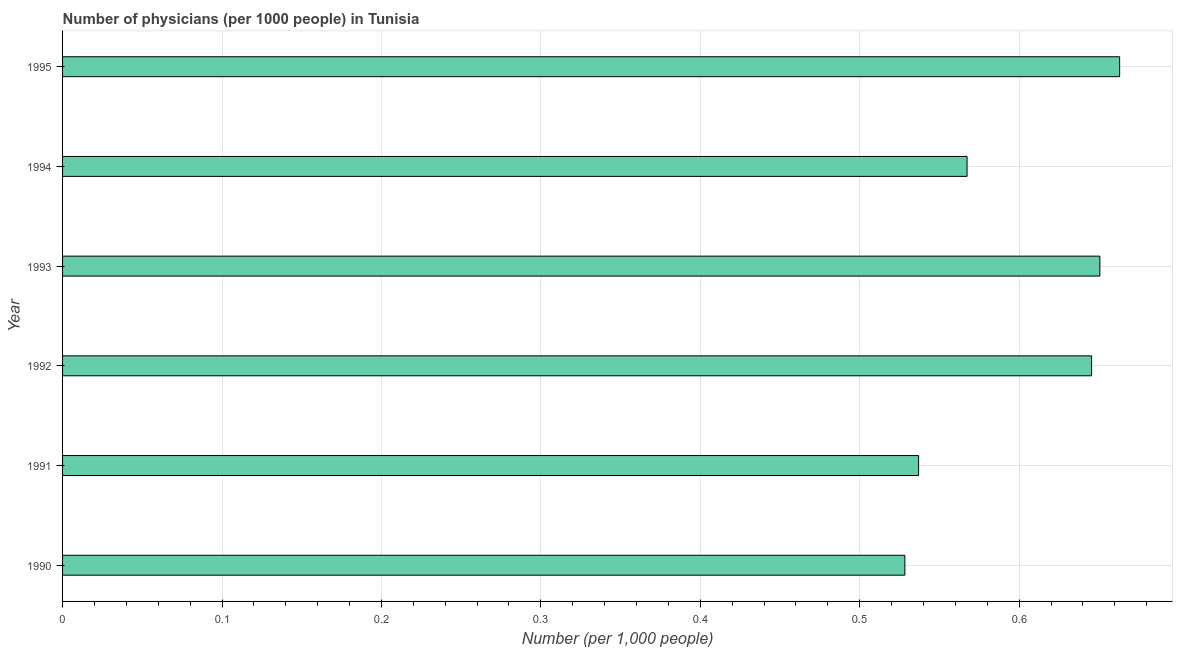Does the graph contain grids?
Offer a terse response. Yes. What is the title of the graph?
Offer a very short reply. Number of physicians (per 1000 people) in Tunisia. What is the label or title of the X-axis?
Give a very brief answer. Number (per 1,0 people). What is the label or title of the Y-axis?
Offer a terse response. Year. What is the number of physicians in 1991?
Your response must be concise. 0.54. Across all years, what is the maximum number of physicians?
Provide a succinct answer. 0.66. Across all years, what is the minimum number of physicians?
Provide a short and direct response. 0.53. In which year was the number of physicians minimum?
Your answer should be compact. 1990. What is the sum of the number of physicians?
Your response must be concise. 3.59. What is the difference between the number of physicians in 1991 and 1994?
Provide a short and direct response. -0.03. What is the average number of physicians per year?
Make the answer very short. 0.6. What is the median number of physicians?
Provide a short and direct response. 0.61. What is the ratio of the number of physicians in 1991 to that in 1994?
Offer a terse response. 0.95. Is the number of physicians in 1993 less than that in 1994?
Your answer should be very brief. No. Is the difference between the number of physicians in 1990 and 1991 greater than the difference between any two years?
Your answer should be very brief. No. What is the difference between the highest and the second highest number of physicians?
Your answer should be compact. 0.01. Is the sum of the number of physicians in 1992 and 1995 greater than the maximum number of physicians across all years?
Provide a short and direct response. Yes. What is the difference between the highest and the lowest number of physicians?
Keep it short and to the point. 0.13. How many bars are there?
Keep it short and to the point. 6. What is the Number (per 1,000 people) of 1990?
Give a very brief answer. 0.53. What is the Number (per 1,000 people) of 1991?
Your answer should be compact. 0.54. What is the Number (per 1,000 people) in 1992?
Offer a very short reply. 0.65. What is the Number (per 1,000 people) of 1993?
Your answer should be compact. 0.65. What is the Number (per 1,000 people) in 1994?
Ensure brevity in your answer.  0.57. What is the Number (per 1,000 people) of 1995?
Offer a terse response. 0.66. What is the difference between the Number (per 1,000 people) in 1990 and 1991?
Your answer should be very brief. -0.01. What is the difference between the Number (per 1,000 people) in 1990 and 1992?
Ensure brevity in your answer.  -0.12. What is the difference between the Number (per 1,000 people) in 1990 and 1993?
Make the answer very short. -0.12. What is the difference between the Number (per 1,000 people) in 1990 and 1994?
Provide a short and direct response. -0.04. What is the difference between the Number (per 1,000 people) in 1990 and 1995?
Offer a terse response. -0.13. What is the difference between the Number (per 1,000 people) in 1991 and 1992?
Make the answer very short. -0.11. What is the difference between the Number (per 1,000 people) in 1991 and 1993?
Provide a succinct answer. -0.11. What is the difference between the Number (per 1,000 people) in 1991 and 1994?
Offer a very short reply. -0.03. What is the difference between the Number (per 1,000 people) in 1991 and 1995?
Your answer should be compact. -0.13. What is the difference between the Number (per 1,000 people) in 1992 and 1993?
Keep it short and to the point. -0.01. What is the difference between the Number (per 1,000 people) in 1992 and 1994?
Provide a short and direct response. 0.08. What is the difference between the Number (per 1,000 people) in 1992 and 1995?
Give a very brief answer. -0.02. What is the difference between the Number (per 1,000 people) in 1993 and 1994?
Your answer should be very brief. 0.08. What is the difference between the Number (per 1,000 people) in 1993 and 1995?
Make the answer very short. -0.01. What is the difference between the Number (per 1,000 people) in 1994 and 1995?
Your answer should be very brief. -0.1. What is the ratio of the Number (per 1,000 people) in 1990 to that in 1991?
Provide a short and direct response. 0.98. What is the ratio of the Number (per 1,000 people) in 1990 to that in 1992?
Make the answer very short. 0.82. What is the ratio of the Number (per 1,000 people) in 1990 to that in 1993?
Provide a short and direct response. 0.81. What is the ratio of the Number (per 1,000 people) in 1990 to that in 1994?
Offer a very short reply. 0.93. What is the ratio of the Number (per 1,000 people) in 1990 to that in 1995?
Provide a short and direct response. 0.8. What is the ratio of the Number (per 1,000 people) in 1991 to that in 1992?
Your answer should be very brief. 0.83. What is the ratio of the Number (per 1,000 people) in 1991 to that in 1993?
Make the answer very short. 0.82. What is the ratio of the Number (per 1,000 people) in 1991 to that in 1994?
Ensure brevity in your answer.  0.95. What is the ratio of the Number (per 1,000 people) in 1991 to that in 1995?
Your answer should be very brief. 0.81. What is the ratio of the Number (per 1,000 people) in 1992 to that in 1993?
Give a very brief answer. 0.99. What is the ratio of the Number (per 1,000 people) in 1992 to that in 1994?
Your response must be concise. 1.14. What is the ratio of the Number (per 1,000 people) in 1993 to that in 1994?
Offer a terse response. 1.15. What is the ratio of the Number (per 1,000 people) in 1993 to that in 1995?
Give a very brief answer. 0.98. What is the ratio of the Number (per 1,000 people) in 1994 to that in 1995?
Provide a succinct answer. 0.86. 